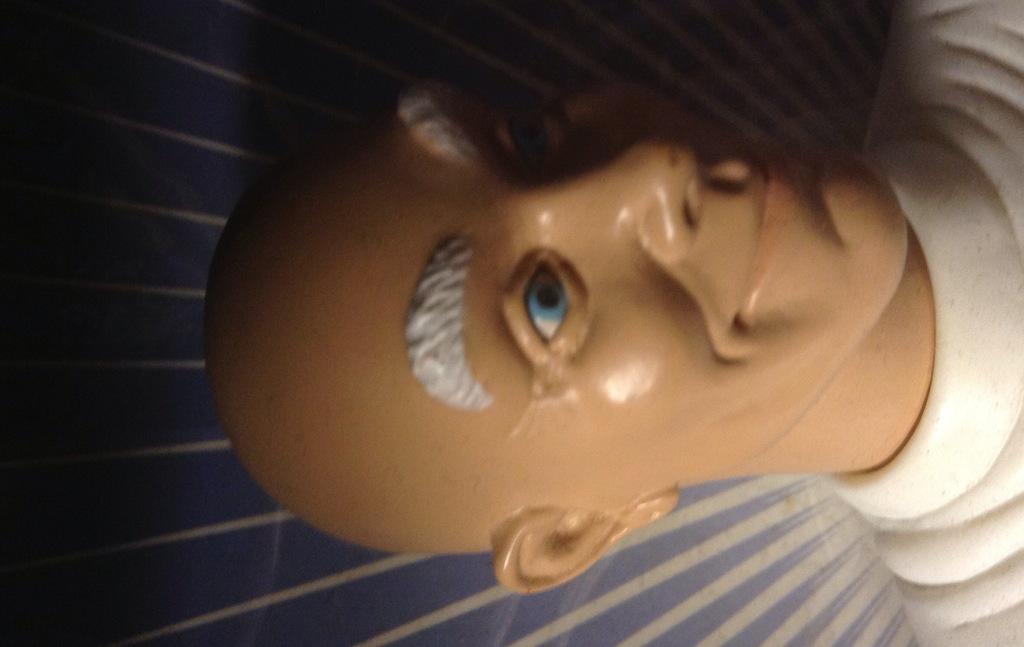How would you summarize this image in a sentence or two? In this image we can see a mannequin. 